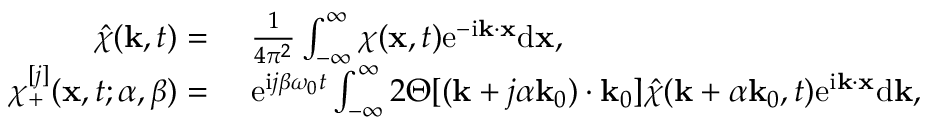Convert formula to latex. <formula><loc_0><loc_0><loc_500><loc_500>\begin{array} { r l } { \hat { \chi } ( k , t ) = } & { \frac { 1 } { 4 \pi ^ { 2 } } \int _ { - \infty } ^ { \infty } \chi ( x , t ) e ^ { - i k \cdot x } d x , } \\ { \chi _ { + } ^ { [ j ] } ( x , t ; \alpha , \beta ) = } & { e ^ { i j \beta \omega _ { 0 } t } \int _ { - \infty } ^ { \infty } 2 \Theta [ ( k + j \alpha k _ { 0 } ) \cdot k _ { 0 } ] \hat { \chi } ( k + \alpha k _ { 0 } , t ) e ^ { i k \cdot x } d k , } \end{array}</formula> 